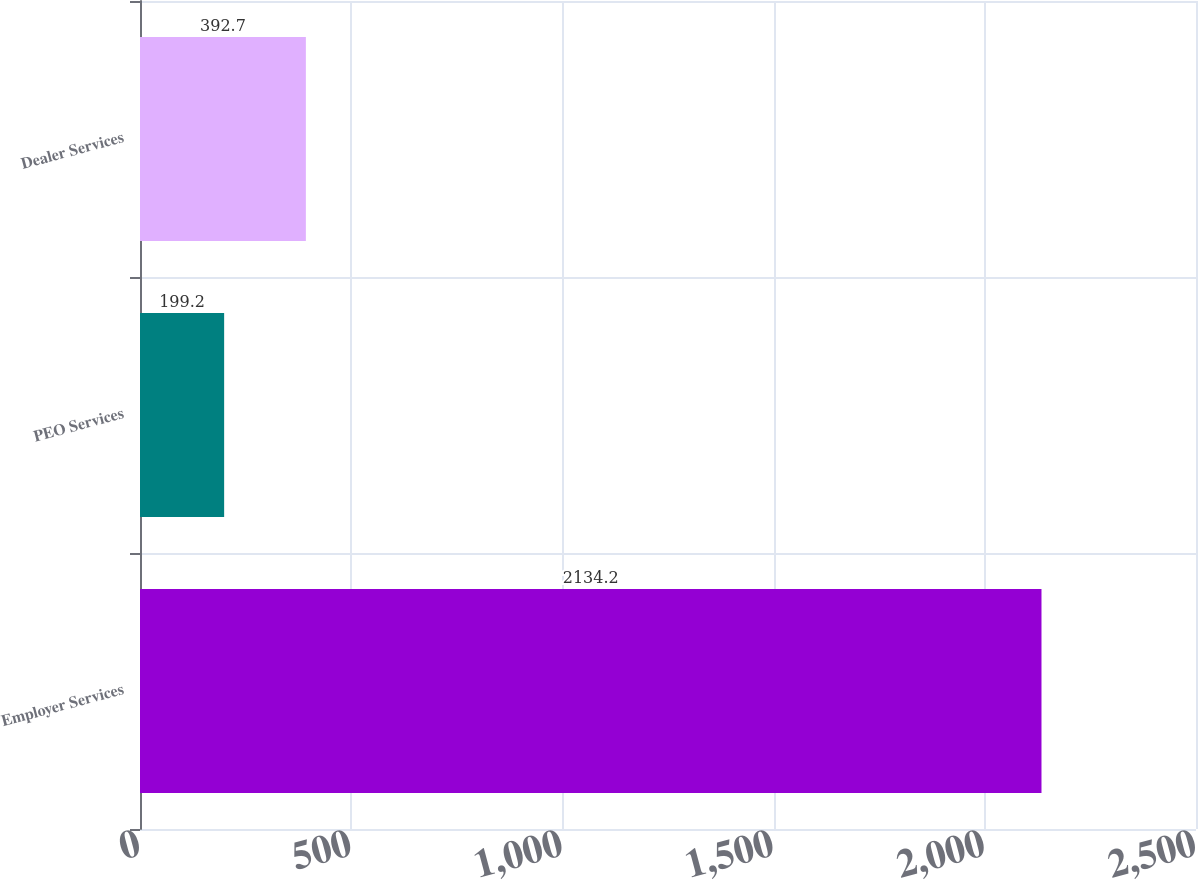<chart> <loc_0><loc_0><loc_500><loc_500><bar_chart><fcel>Employer Services<fcel>PEO Services<fcel>Dealer Services<nl><fcel>2134.2<fcel>199.2<fcel>392.7<nl></chart> 